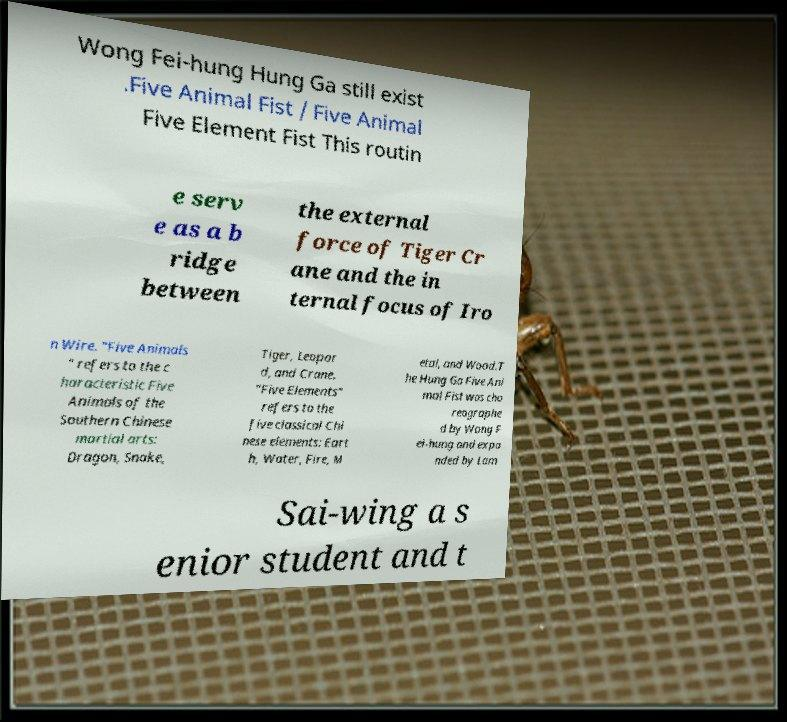For documentation purposes, I need the text within this image transcribed. Could you provide that? Wong Fei-hung Hung Ga still exist .Five Animal Fist / Five Animal Five Element Fist This routin e serv e as a b ridge between the external force of Tiger Cr ane and the in ternal focus of Iro n Wire. "Five Animals " refers to the c haracteristic Five Animals of the Southern Chinese martial arts: Dragon, Snake, Tiger, Leopar d, and Crane. "Five Elements" refers to the five classical Chi nese elements: Eart h, Water, Fire, M etal, and Wood.T he Hung Ga Five Ani mal Fist was cho reographe d by Wong F ei-hung and expa nded by Lam Sai-wing a s enior student and t 